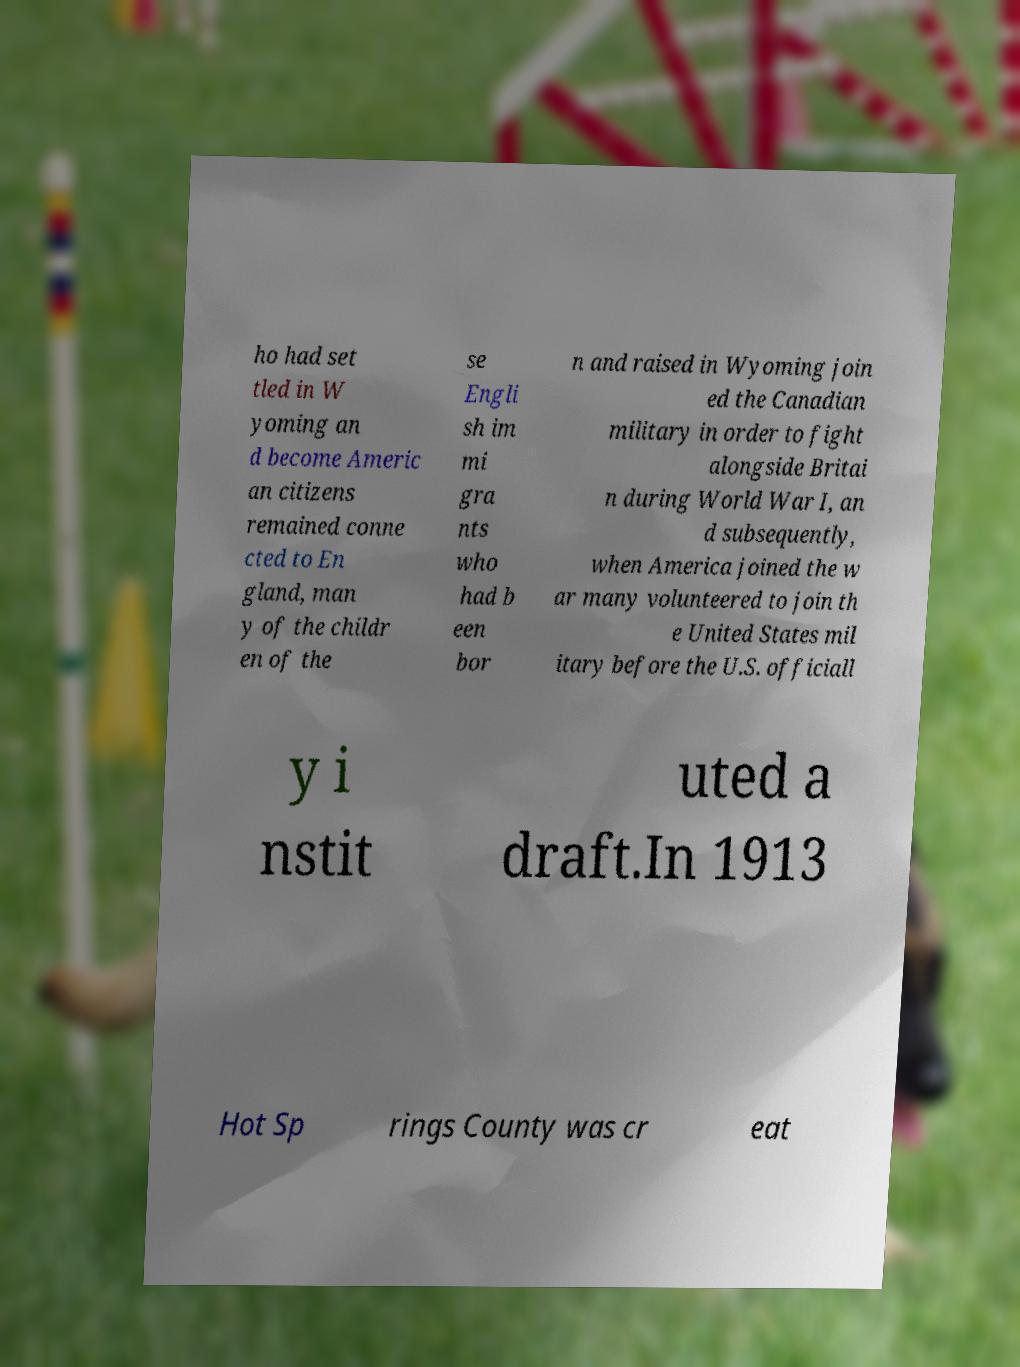Please identify and transcribe the text found in this image. ho had set tled in W yoming an d become Americ an citizens remained conne cted to En gland, man y of the childr en of the se Engli sh im mi gra nts who had b een bor n and raised in Wyoming join ed the Canadian military in order to fight alongside Britai n during World War I, an d subsequently, when America joined the w ar many volunteered to join th e United States mil itary before the U.S. officiall y i nstit uted a draft.In 1913 Hot Sp rings County was cr eat 